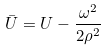Convert formula to latex. <formula><loc_0><loc_0><loc_500><loc_500>\bar { U } = U - \frac { \omega ^ { 2 } } { 2 \rho ^ { 2 } }</formula> 